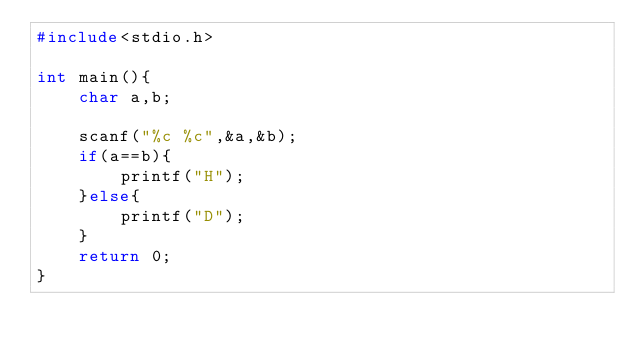<code> <loc_0><loc_0><loc_500><loc_500><_C_>#include<stdio.h>

int main(){
    char a,b;

    scanf("%c %c",&a,&b); 
    if(a==b){
        printf("H");
    }else{
        printf("D");
    }
    return 0;
}</code> 